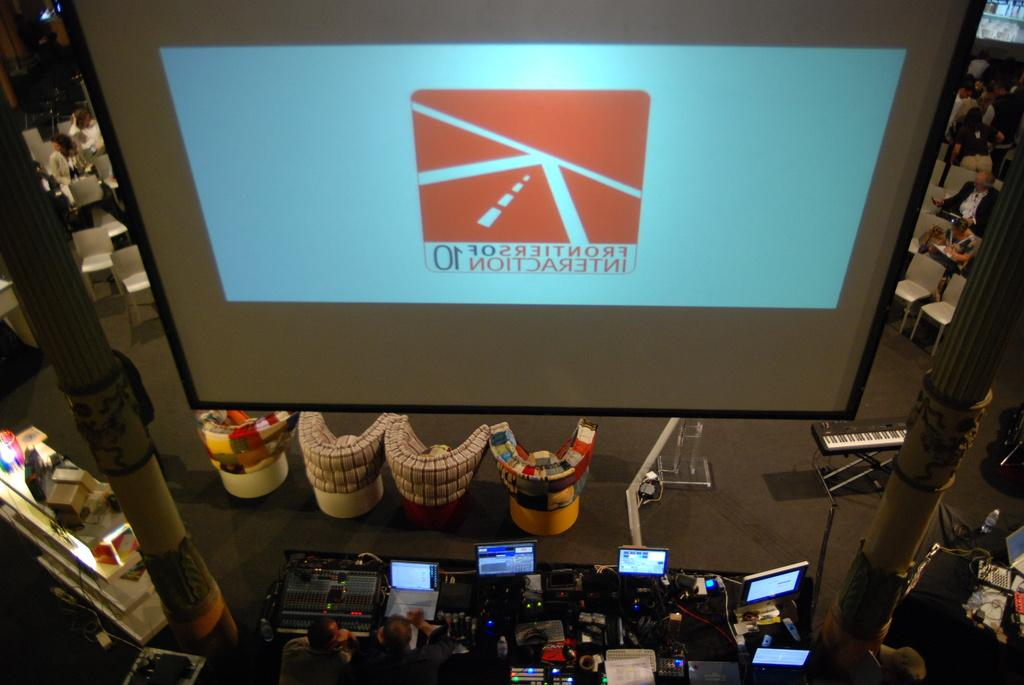<image>
Present a compact description of the photo's key features. a large screem with the number 10 written backwards 